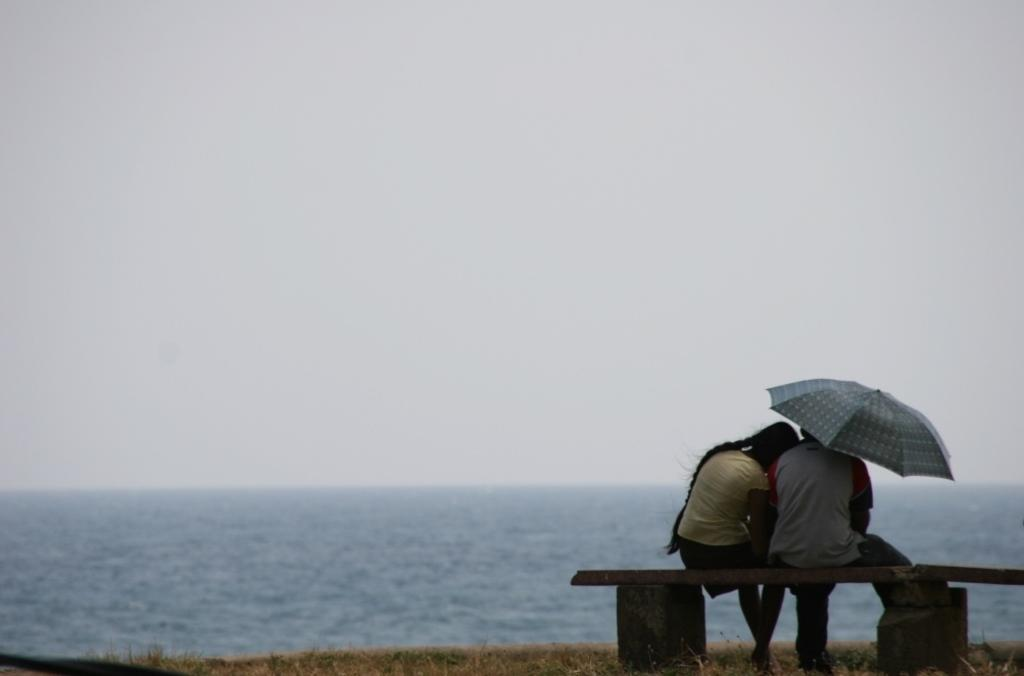What are the people in the image doing? The people in the image are sitting on a bench. Is there any object being held by one of the people? Yes, one person is holding an umbrella. What can be seen in the image besides the people and the bench? There is water visible in the image. What is visible in the background of the image? The sky is visible in the background of the image. How many sisters are sitting on the bench in the image? There is no mention of sisters in the image, and the number of people sitting on the bench is not specified. 